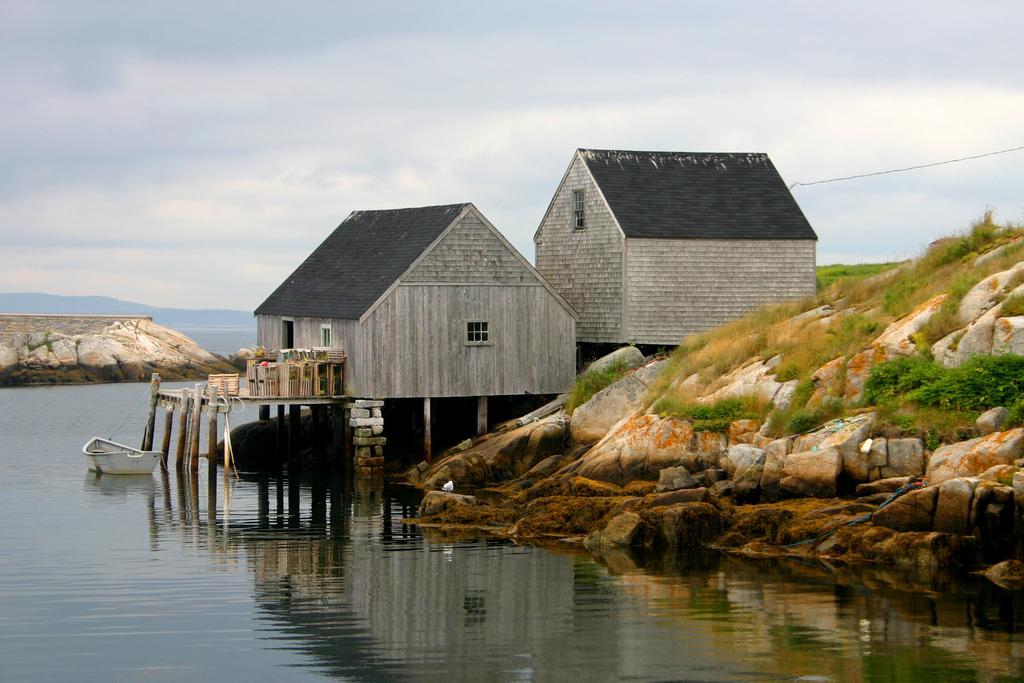How would you summarize this image in a sentence or two? In this image we can see the houses with the roofs. We can also see the stone hills, grass and also the boat on the surface of the water. In the background we can see the sky with some clouds. 